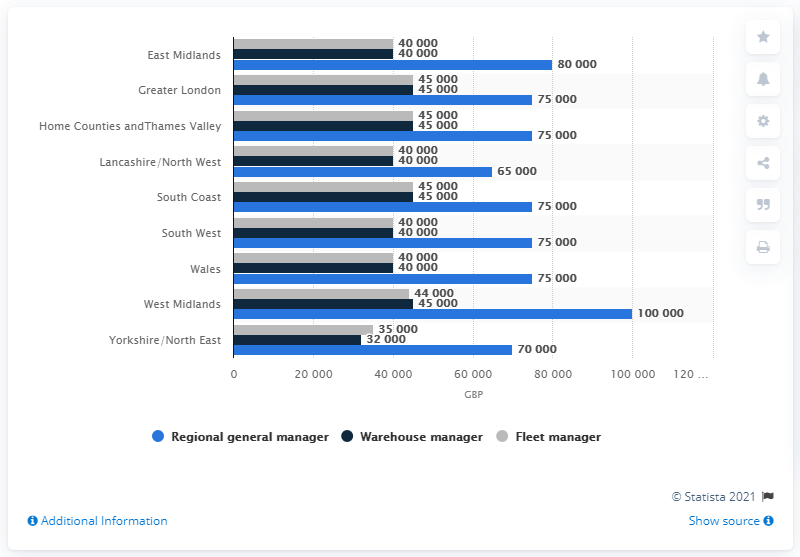Draw attention to some important aspects in this diagram. In 2014, the average salary for warehouse managers and fleet managers in London was approximately 45,000. 